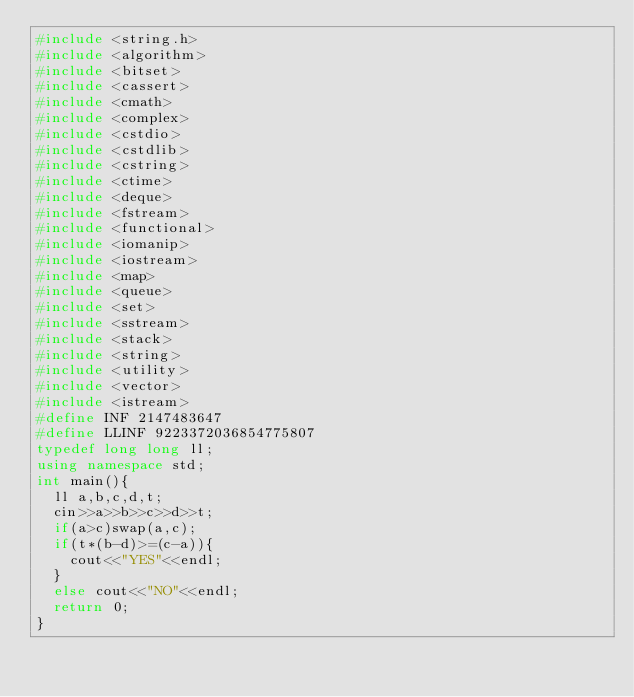<code> <loc_0><loc_0><loc_500><loc_500><_C++_>#include <string.h>
#include <algorithm>
#include <bitset>
#include <cassert>
#include <cmath>
#include <complex>
#include <cstdio>
#include <cstdlib>
#include <cstring>
#include <ctime>
#include <deque>
#include <fstream>
#include <functional>
#include <iomanip>
#include <iostream>
#include <map>
#include <queue>
#include <set>
#include <sstream>
#include <stack>
#include <string>
#include <utility>
#include <vector>
#include <istream>
#define INF 2147483647
#define LLINF 9223372036854775807
typedef long long ll;
using namespace std;
int main(){
	ll a,b,c,d,t;
	cin>>a>>b>>c>>d>>t;
	if(a>c)swap(a,c);
	if(t*(b-d)>=(c-a)){
		cout<<"YES"<<endl;
	}
	else cout<<"NO"<<endl;
	return 0;
}</code> 